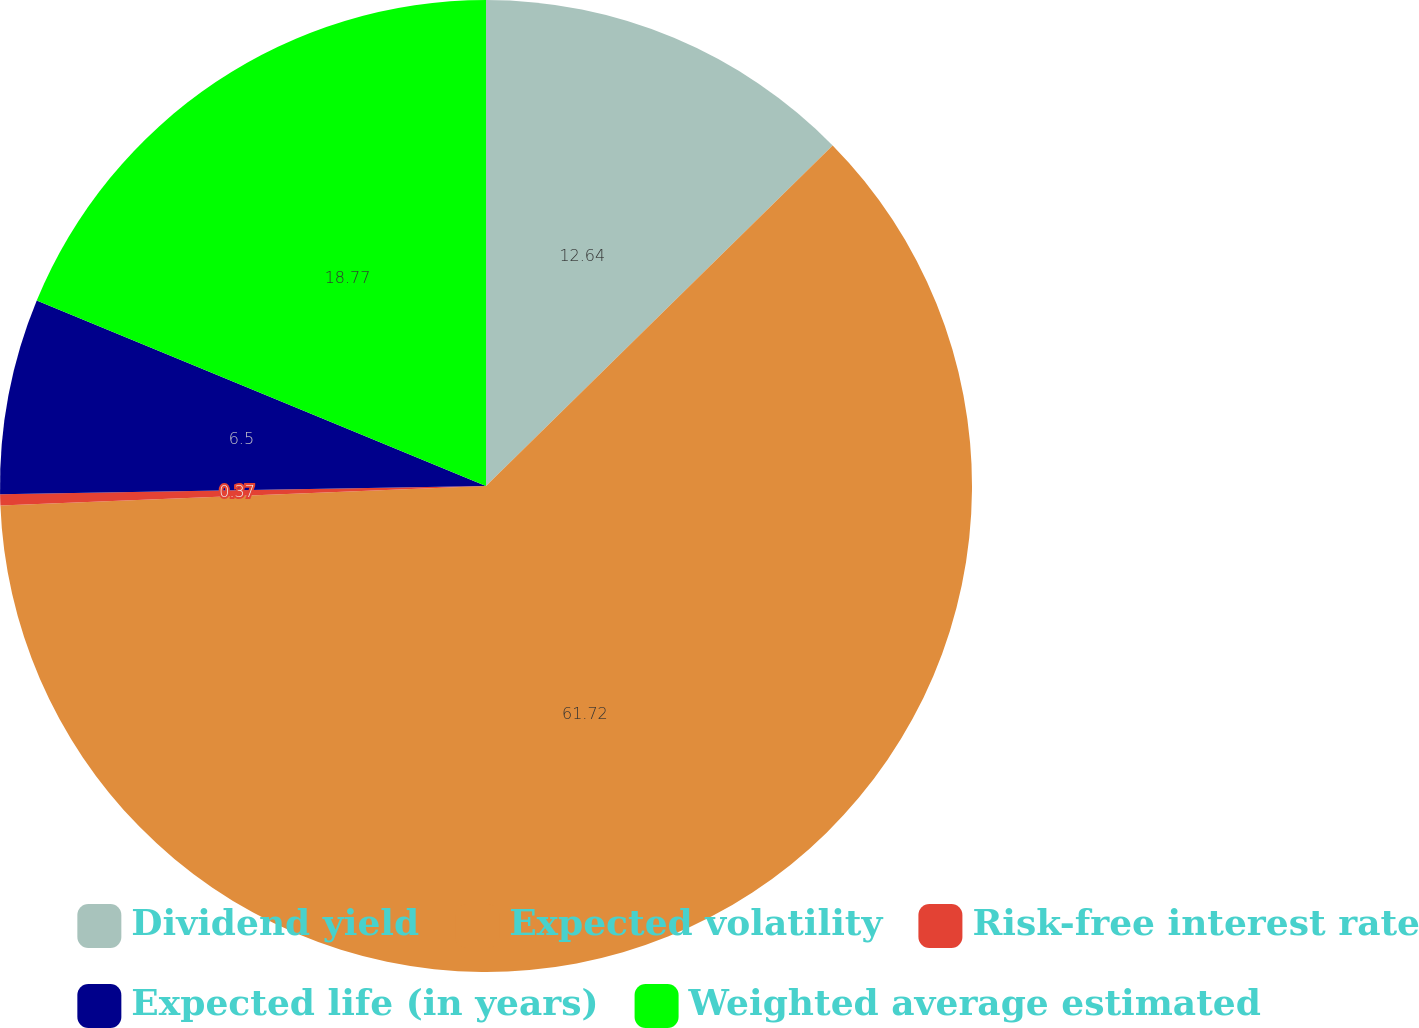Convert chart. <chart><loc_0><loc_0><loc_500><loc_500><pie_chart><fcel>Dividend yield<fcel>Expected volatility<fcel>Risk-free interest rate<fcel>Expected life (in years)<fcel>Weighted average estimated<nl><fcel>12.64%<fcel>61.72%<fcel>0.37%<fcel>6.5%<fcel>18.77%<nl></chart> 